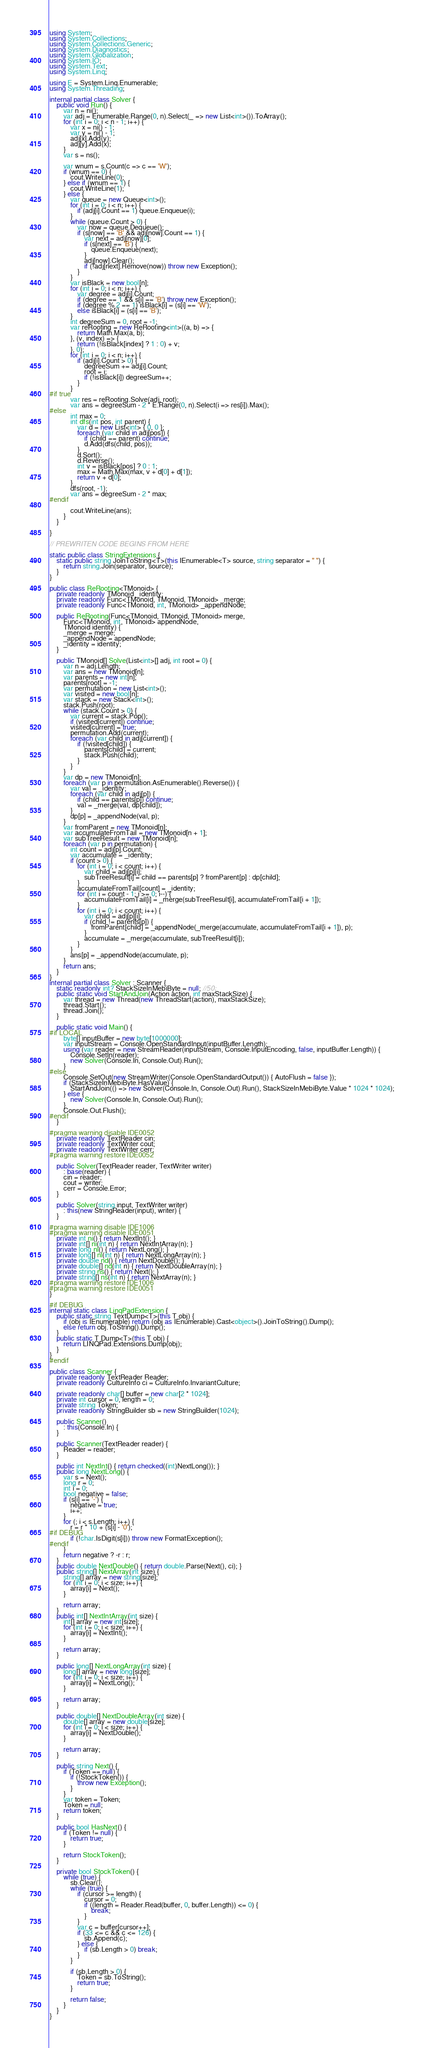<code> <loc_0><loc_0><loc_500><loc_500><_C#_>using System;
using System.Collections;
using System.Collections.Generic;
using System.Diagnostics;
using System.Globalization;
using System.IO;
using System.Text;
using System.Linq;

using E = System.Linq.Enumerable;
using System.Threading;

internal partial class Solver {
    public void Run() {
        var n = ni();
        var adj = Enumerable.Range(0, n).Select(_ => new List<int>()).ToArray();
        for (int i = 0; i < n - 1; i++) {
            var x = ni() - 1;
            var y = ni() - 1;
            adj[x].Add(y);
            adj[y].Add(x);
        }
        var s = ns();

        var wnum = s.Count(c => c == 'W');
        if (wnum == 0) {
            cout.WriteLine(0);
        } else if (wnum == 1) {
            cout.WriteLine(1);
        } else {
            var queue = new Queue<int>();
            for (int i = 0; i < n; i++) {
                if (adj[i].Count == 1) queue.Enqueue(i);
            }
            while (queue.Count > 0) {
                var now = queue.Dequeue();
                if (s[now] == 'B' && adj[now].Count == 1) {
                    var next = adj[now][0];
                    if (s[next] == 'B') {
                        queue.Enqueue(next);
                    }
                    adj[now].Clear();
                    if (!adj[next].Remove(now)) throw new Exception();
                }
            }
            var isBlack = new bool[n];
            for (int i = 0; i < n; i++) {
                var degree = adj[i].Count;
                if (degree == 1 && s[i] == 'B') throw new Exception();
                if (degree % 2 == 1) isBlack[i] = (s[i] == 'W');
                else isBlack[i] = (s[i] == 'B');
            }
            int degreeSum = 0, root = -1;
            var reRooting = new ReRooting<int>((a, b) => {
                return Math.Max(a, b);
            }, (v, index) => {
                return (!isBlack[index] ? 1 : 0) + v;
            }, 0);
            for (int i = 0; i < n; i++) {
                if (adj[i].Count > 0) {
                    degreeSum += adj[i].Count;
                    root = i;
                    if (!isBlack[i]) degreeSum++;
                }
            }
#if true
            var res = reRooting.Solve(adj, root);
            var ans = degreeSum - 2 * E.Range(0, n).Select(i => res[i]).Max();
#else
            int max = 0;
            int dfs(int pos, int parent) {
                var d = new List<int> { 0, 0 };
                foreach (var child in adj[pos]) {
                    if (child == parent) continue;
                    d.Add(dfs(child, pos));
                }
                d.Sort();
                d.Reverse();
                int v = isBlack[pos] ? 0 : 1;
                max = Math.Max(max, v + d[0] + d[1]);
                return v + d[0];
            }
            dfs(root, -1);
            var ans = degreeSum - 2 * max;
#endif

            cout.WriteLine(ans);
        }
    }

}

// PREWRITEN CODE BEGINS FROM HERE

static public class StringExtensions {
    static public string JoinToString<T>(this IEnumerable<T> source, string separator = " ") {
        return string.Join(separator, source);
    }
}

public class ReRooting<TMonoid> {
    private readonly TMonoid _identity;
    private readonly Func<TMonoid, TMonoid, TMonoid> _merge;
    private readonly Func<TMonoid, int, TMonoid> _appendNode;

    public ReRooting(Func<TMonoid, TMonoid, TMonoid> merge,
        Func<TMonoid, int, TMonoid> appendNode,
        TMonoid identity) {
        _merge = merge;
        _appendNode = appendNode;
        _identity = identity;
    }

    public TMonoid[] Solve(List<int>[] adj, int root = 0) {
        var n = adj.Length;
        var ans = new TMonoid[n];
        var parents = new int[n];
        parents[root] = -1;
        var permutation = new List<int>();
        var visited = new bool[n];
        var stack = new Stack<int>();
        stack.Push(root);
        while (stack.Count > 0) {
            var current = stack.Pop();
            if (visited[current]) continue;
            visited[current] = true;
            permutation.Add(current);
            foreach (var child in adj[current]) {
                if (!visited[child]) {
                    parents[child] = current;
                    stack.Push(child);
                }
            }
        }
        var dp = new TMonoid[n];
        foreach (var p in permutation.AsEnumerable().Reverse()) {
            var val = _identity;
            foreach (var child in adj[p]) {
                if (child == parents[p]) continue;
                val = _merge(val, dp[child]);
            }
            dp[p] = _appendNode(val, p);
        }
        var fromParent = new TMonoid[n];
        var accumulateFromTail = new TMonoid[n + 1];
        var subTreeResult = new TMonoid[n];
        foreach (var p in permutation) {
            int count = adj[p].Count;
            var accumulate = _identity;
            if (count > 0) {
                for (int i = 0; i < count; i++) {
                    var child = adj[p][i];
                    subTreeResult[i] = child == parents[p] ? fromParent[p] : dp[child];
                }
                accumulateFromTail[count] = _identity;
                for (int i = count - 1; i >= 0; i--) {
                    accumulateFromTail[i] = _merge(subTreeResult[i], accumulateFromTail[i + 1]);
                }
                for (int i = 0; i < count; i++) {
                    var child = adj[p][i];
                    if (child != parents[p]) {
                        fromParent[child] = _appendNode(_merge(accumulate, accumulateFromTail[i + 1]), p);
                    }
                    accumulate = _merge(accumulate, subTreeResult[i]);
                }
            }
            ans[p] = _appendNode(accumulate, p);
        }
        return ans;
    }
}
internal partial class Solver : Scanner {
    static readonly int? StackSizeInMebiByte = null; //50;
    public static void StartAndJoin(Action action, int maxStackSize) {
        var thread = new Thread(new ThreadStart(action), maxStackSize);
        thread.Start();
        thread.Join();
    }

    public static void Main() {
#if LOCAL
        byte[] inputBuffer = new byte[1000000];
        var inputStream = Console.OpenStandardInput(inputBuffer.Length);
        using (var reader = new StreamReader(inputStream, Console.InputEncoding, false, inputBuffer.Length)) {
            Console.SetIn(reader);
            new Solver(Console.In, Console.Out).Run();
        }
#else
        Console.SetOut(new StreamWriter(Console.OpenStandardOutput()) { AutoFlush = false });
        if (StackSizeInMebiByte.HasValue) {
            StartAndJoin(() => new Solver(Console.In, Console.Out).Run(), StackSizeInMebiByte.Value * 1024 * 1024);
        } else {
            new Solver(Console.In, Console.Out).Run();
        }
        Console.Out.Flush();
#endif
    }

#pragma warning disable IDE0052
    private readonly TextReader cin;
    private readonly TextWriter cout;
    private readonly TextWriter cerr;
#pragma warning restore IDE0052

    public Solver(TextReader reader, TextWriter writer)
        : base(reader) {
        cin = reader;
        cout = writer;
        cerr = Console.Error;
    }

    public Solver(string input, TextWriter writer)
        : this(new StringReader(input), writer) {
    }

#pragma warning disable IDE1006
#pragma warning disable IDE0051
    private int ni() { return NextInt(); }
    private int[] ni(int n) { return NextIntArray(n); }
    private long nl() { return NextLong(); }
    private long[] nl(int n) { return NextLongArray(n); }
    private double nd() { return NextDouble(); }
    private double[] nd(int n) { return NextDoubleArray(n); }
    private string ns() { return Next(); }
    private string[] ns(int n) { return NextArray(n); }
#pragma warning restore IDE1006
#pragma warning restore IDE0051
}

#if DEBUG
internal static class LinqPadExtension {
    public static string TextDump<T>(this T obj) {
        if (obj is IEnumerable) return (obj as IEnumerable).Cast<object>().JoinToString().Dump();
        else return obj.ToString().Dump();
    }
    public static T Dump<T>(this T obj) {
        return LINQPad.Extensions.Dump(obj);
    }
}
#endif

public class Scanner {
    private readonly TextReader Reader;
    private readonly CultureInfo ci = CultureInfo.InvariantCulture;

    private readonly char[] buffer = new char[2 * 1024];
    private int cursor = 0, length = 0;
    private string Token;
    private readonly StringBuilder sb = new StringBuilder(1024);

    public Scanner()
        : this(Console.In) {
    }

    public Scanner(TextReader reader) {
        Reader = reader;
    }

    public int NextInt() { return checked((int)NextLong()); }
    public long NextLong() {
        var s = Next();
        long r = 0;
        int i = 0;
        bool negative = false;
        if (s[i] == '-') {
            negative = true;
            i++;
        }
        for (; i < s.Length; i++) {
            r = r * 10 + (s[i] - '0');
#if DEBUG
            if (!char.IsDigit(s[i])) throw new FormatException();
#endif
        }
        return negative ? -r : r;
    }
    public double NextDouble() { return double.Parse(Next(), ci); }
    public string[] NextArray(int size) {
        string[] array = new string[size];
        for (int i = 0; i < size; i++) {
            array[i] = Next();
        }

        return array;
    }
    public int[] NextIntArray(int size) {
        int[] array = new int[size];
        for (int i = 0; i < size; i++) {
            array[i] = NextInt();
        }

        return array;
    }

    public long[] NextLongArray(int size) {
        long[] array = new long[size];
        for (int i = 0; i < size; i++) {
            array[i] = NextLong();
        }

        return array;
    }

    public double[] NextDoubleArray(int size) {
        double[] array = new double[size];
        for (int i = 0; i < size; i++) {
            array[i] = NextDouble();
        }

        return array;
    }

    public string Next() {
        if (Token == null) {
            if (!StockToken()) {
                throw new Exception();
            }
        }
        var token = Token;
        Token = null;
        return token;
    }

    public bool HasNext() {
        if (Token != null) {
            return true;
        }

        return StockToken();
    }

    private bool StockToken() {
        while (true) {
            sb.Clear();
            while (true) {
                if (cursor >= length) {
                    cursor = 0;
                    if ((length = Reader.Read(buffer, 0, buffer.Length)) <= 0) {
                        break;
                    }
                }
                var c = buffer[cursor++];
                if (33 <= c && c <= 126) {
                    sb.Append(c);
                } else {
                    if (sb.Length > 0) break;
                }
            }

            if (sb.Length > 0) {
                Token = sb.ToString();
                return true;
            }

            return false;
        }
    }
}</code> 